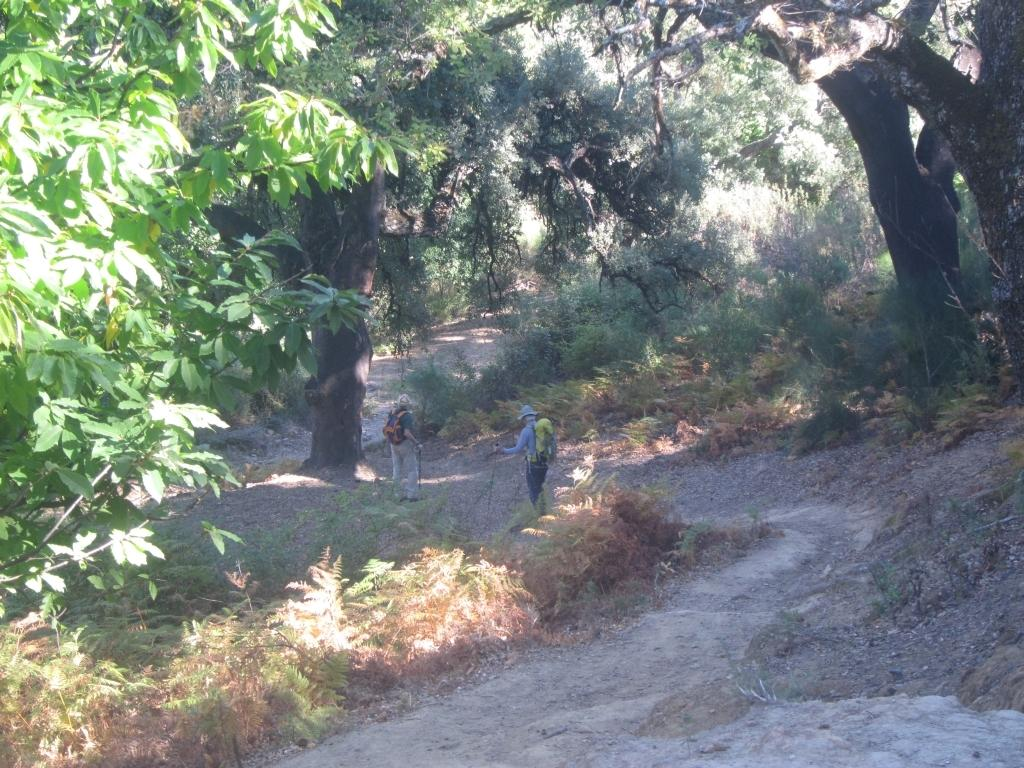How many people are in the image? There are two persons in the image. What are the persons carrying? The persons are carrying backpacks. What can be seen at the bottom of the image? There are plants at the bottom of the image. What is visible in the background of the image? There are trees in the background of the image. What type of bird can be seen flying over the persons in the image? There is no bird visible in the image. How does the sheet affect the pollution in the image? There is no sheet or pollution mentioned in the image. 